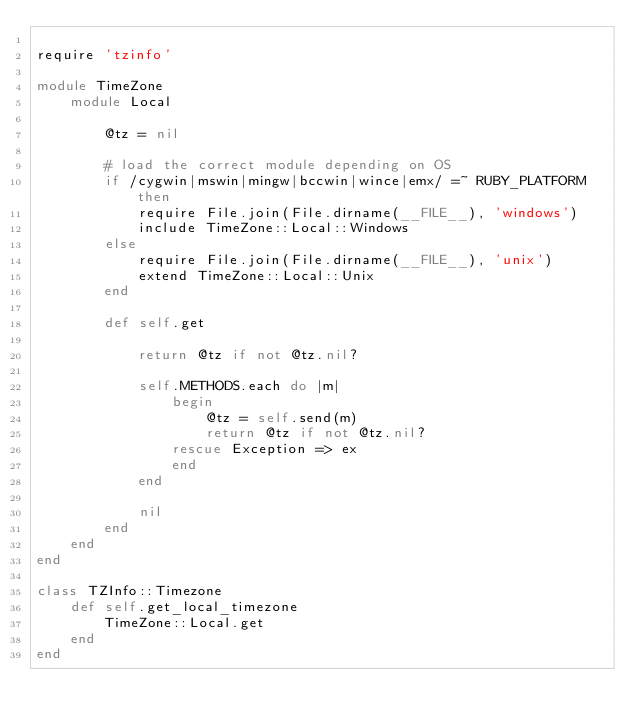Convert code to text. <code><loc_0><loc_0><loc_500><loc_500><_Ruby_>
require 'tzinfo'

module TimeZone
    module Local

        @tz = nil

        # load the correct module depending on OS
        if /cygwin|mswin|mingw|bccwin|wince|emx/ =~ RUBY_PLATFORM then
            require File.join(File.dirname(__FILE__), 'windows')
            include TimeZone::Local::Windows
        else
            require File.join(File.dirname(__FILE__), 'unix')
            extend TimeZone::Local::Unix
        end

        def self.get

            return @tz if not @tz.nil?

            self.METHODS.each do |m|
                begin
                    @tz = self.send(m)
                    return @tz if not @tz.nil?
                rescue Exception => ex
                end
            end

            nil
        end
    end
end

class TZInfo::Timezone
    def self.get_local_timezone
        TimeZone::Local.get
    end
end
</code> 